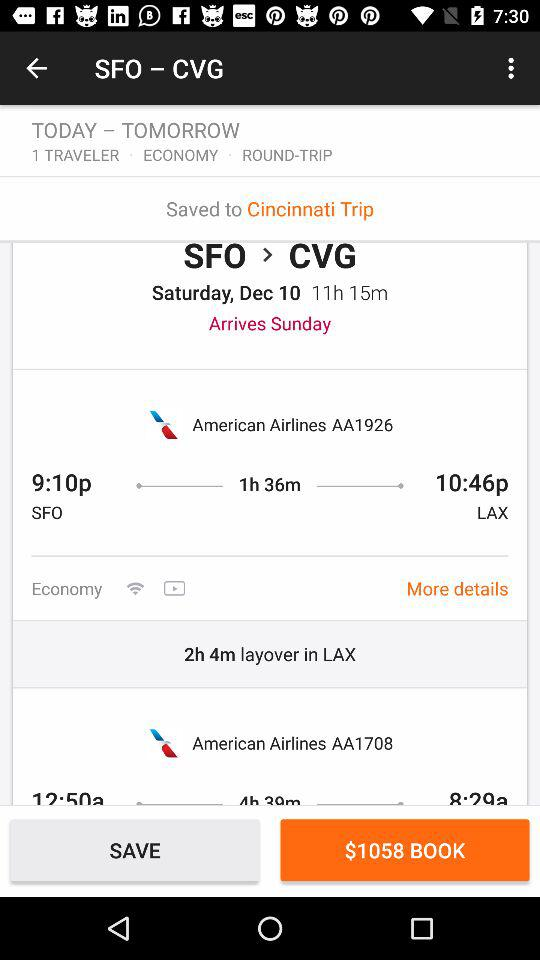How much is the cost of booking? The cost of booking is $1058. 